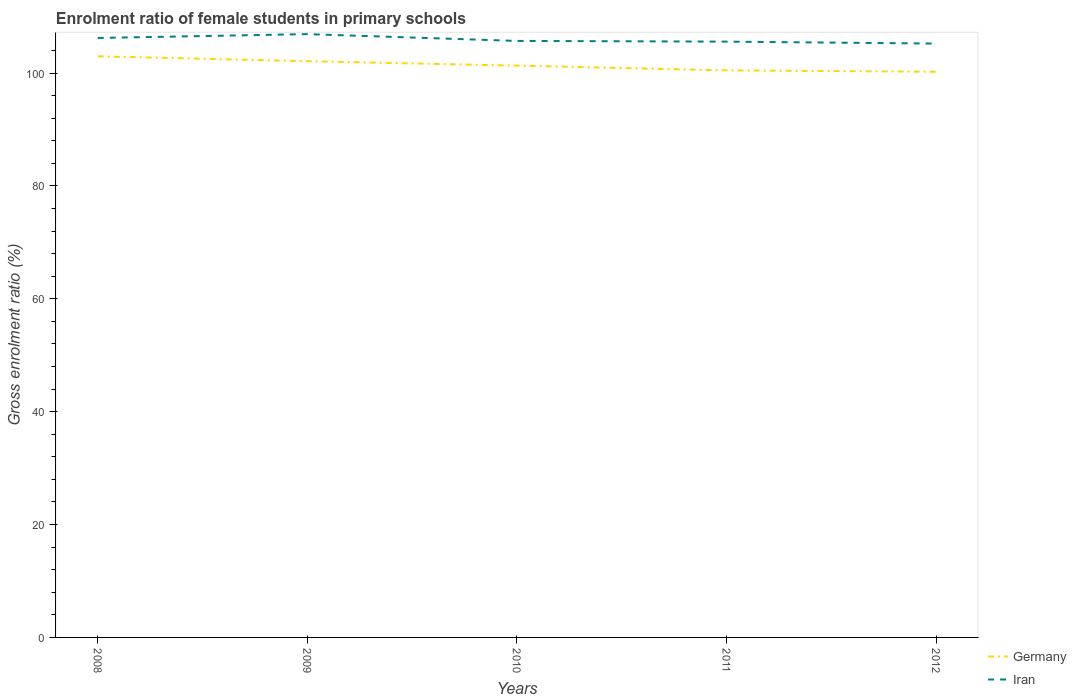Is the number of lines equal to the number of legend labels?
Give a very brief answer. Yes. Across all years, what is the maximum enrolment ratio of female students in primary schools in Iran?
Keep it short and to the point. 105.23. In which year was the enrolment ratio of female students in primary schools in Iran maximum?
Offer a very short reply. 2012. What is the total enrolment ratio of female students in primary schools in Germany in the graph?
Keep it short and to the point. 1.65. What is the difference between the highest and the second highest enrolment ratio of female students in primary schools in Germany?
Your answer should be compact. 2.74. What is the difference between the highest and the lowest enrolment ratio of female students in primary schools in Iran?
Your response must be concise. 2. How many lines are there?
Keep it short and to the point. 2. How many years are there in the graph?
Provide a succinct answer. 5. Are the values on the major ticks of Y-axis written in scientific E-notation?
Offer a terse response. No. Does the graph contain any zero values?
Keep it short and to the point. No. Does the graph contain grids?
Keep it short and to the point. No. How are the legend labels stacked?
Offer a very short reply. Vertical. What is the title of the graph?
Your response must be concise. Enrolment ratio of female students in primary schools. What is the Gross enrolment ratio (%) in Germany in 2008?
Ensure brevity in your answer.  102.98. What is the Gross enrolment ratio (%) of Iran in 2008?
Provide a short and direct response. 106.23. What is the Gross enrolment ratio (%) in Germany in 2009?
Your answer should be compact. 102.11. What is the Gross enrolment ratio (%) in Iran in 2009?
Your answer should be very brief. 106.91. What is the Gross enrolment ratio (%) in Germany in 2010?
Your answer should be compact. 101.33. What is the Gross enrolment ratio (%) in Iran in 2010?
Make the answer very short. 105.7. What is the Gross enrolment ratio (%) in Germany in 2011?
Provide a short and direct response. 100.48. What is the Gross enrolment ratio (%) in Iran in 2011?
Your response must be concise. 105.58. What is the Gross enrolment ratio (%) of Germany in 2012?
Your answer should be compact. 100.24. What is the Gross enrolment ratio (%) of Iran in 2012?
Provide a short and direct response. 105.23. Across all years, what is the maximum Gross enrolment ratio (%) in Germany?
Provide a short and direct response. 102.98. Across all years, what is the maximum Gross enrolment ratio (%) in Iran?
Your answer should be compact. 106.91. Across all years, what is the minimum Gross enrolment ratio (%) in Germany?
Ensure brevity in your answer.  100.24. Across all years, what is the minimum Gross enrolment ratio (%) in Iran?
Offer a terse response. 105.23. What is the total Gross enrolment ratio (%) of Germany in the graph?
Make the answer very short. 507.14. What is the total Gross enrolment ratio (%) of Iran in the graph?
Your response must be concise. 529.65. What is the difference between the Gross enrolment ratio (%) in Germany in 2008 and that in 2009?
Provide a succinct answer. 0.87. What is the difference between the Gross enrolment ratio (%) in Iran in 2008 and that in 2009?
Provide a short and direct response. -0.68. What is the difference between the Gross enrolment ratio (%) of Germany in 2008 and that in 2010?
Offer a terse response. 1.65. What is the difference between the Gross enrolment ratio (%) in Iran in 2008 and that in 2010?
Provide a succinct answer. 0.52. What is the difference between the Gross enrolment ratio (%) in Germany in 2008 and that in 2011?
Your response must be concise. 2.5. What is the difference between the Gross enrolment ratio (%) in Iran in 2008 and that in 2011?
Give a very brief answer. 0.65. What is the difference between the Gross enrolment ratio (%) in Germany in 2008 and that in 2012?
Ensure brevity in your answer.  2.74. What is the difference between the Gross enrolment ratio (%) in Germany in 2009 and that in 2010?
Your response must be concise. 0.78. What is the difference between the Gross enrolment ratio (%) of Iran in 2009 and that in 2010?
Your answer should be very brief. 1.2. What is the difference between the Gross enrolment ratio (%) of Germany in 2009 and that in 2011?
Ensure brevity in your answer.  1.63. What is the difference between the Gross enrolment ratio (%) of Iran in 2009 and that in 2011?
Make the answer very short. 1.33. What is the difference between the Gross enrolment ratio (%) in Germany in 2009 and that in 2012?
Your response must be concise. 1.87. What is the difference between the Gross enrolment ratio (%) in Iran in 2009 and that in 2012?
Give a very brief answer. 1.67. What is the difference between the Gross enrolment ratio (%) in Germany in 2010 and that in 2011?
Provide a succinct answer. 0.85. What is the difference between the Gross enrolment ratio (%) of Iran in 2010 and that in 2011?
Offer a terse response. 0.13. What is the difference between the Gross enrolment ratio (%) of Germany in 2010 and that in 2012?
Offer a very short reply. 1.09. What is the difference between the Gross enrolment ratio (%) of Iran in 2010 and that in 2012?
Your answer should be very brief. 0.47. What is the difference between the Gross enrolment ratio (%) in Germany in 2011 and that in 2012?
Provide a succinct answer. 0.24. What is the difference between the Gross enrolment ratio (%) of Iran in 2011 and that in 2012?
Offer a very short reply. 0.34. What is the difference between the Gross enrolment ratio (%) in Germany in 2008 and the Gross enrolment ratio (%) in Iran in 2009?
Ensure brevity in your answer.  -3.93. What is the difference between the Gross enrolment ratio (%) in Germany in 2008 and the Gross enrolment ratio (%) in Iran in 2010?
Offer a terse response. -2.72. What is the difference between the Gross enrolment ratio (%) in Germany in 2008 and the Gross enrolment ratio (%) in Iran in 2011?
Your response must be concise. -2.6. What is the difference between the Gross enrolment ratio (%) of Germany in 2008 and the Gross enrolment ratio (%) of Iran in 2012?
Make the answer very short. -2.25. What is the difference between the Gross enrolment ratio (%) in Germany in 2009 and the Gross enrolment ratio (%) in Iran in 2010?
Offer a very short reply. -3.59. What is the difference between the Gross enrolment ratio (%) of Germany in 2009 and the Gross enrolment ratio (%) of Iran in 2011?
Ensure brevity in your answer.  -3.47. What is the difference between the Gross enrolment ratio (%) of Germany in 2009 and the Gross enrolment ratio (%) of Iran in 2012?
Provide a short and direct response. -3.12. What is the difference between the Gross enrolment ratio (%) of Germany in 2010 and the Gross enrolment ratio (%) of Iran in 2011?
Keep it short and to the point. -4.25. What is the difference between the Gross enrolment ratio (%) of Germany in 2010 and the Gross enrolment ratio (%) of Iran in 2012?
Provide a succinct answer. -3.91. What is the difference between the Gross enrolment ratio (%) in Germany in 2011 and the Gross enrolment ratio (%) in Iran in 2012?
Your response must be concise. -4.75. What is the average Gross enrolment ratio (%) of Germany per year?
Ensure brevity in your answer.  101.43. What is the average Gross enrolment ratio (%) of Iran per year?
Your answer should be compact. 105.93. In the year 2008, what is the difference between the Gross enrolment ratio (%) of Germany and Gross enrolment ratio (%) of Iran?
Give a very brief answer. -3.24. In the year 2009, what is the difference between the Gross enrolment ratio (%) of Germany and Gross enrolment ratio (%) of Iran?
Your response must be concise. -4.8. In the year 2010, what is the difference between the Gross enrolment ratio (%) of Germany and Gross enrolment ratio (%) of Iran?
Offer a very short reply. -4.38. In the year 2011, what is the difference between the Gross enrolment ratio (%) in Germany and Gross enrolment ratio (%) in Iran?
Your response must be concise. -5.1. In the year 2012, what is the difference between the Gross enrolment ratio (%) of Germany and Gross enrolment ratio (%) of Iran?
Your answer should be very brief. -4.99. What is the ratio of the Gross enrolment ratio (%) in Germany in 2008 to that in 2009?
Provide a succinct answer. 1.01. What is the ratio of the Gross enrolment ratio (%) in Iran in 2008 to that in 2009?
Provide a succinct answer. 0.99. What is the ratio of the Gross enrolment ratio (%) in Germany in 2008 to that in 2010?
Your answer should be compact. 1.02. What is the ratio of the Gross enrolment ratio (%) of Germany in 2008 to that in 2011?
Offer a very short reply. 1.02. What is the ratio of the Gross enrolment ratio (%) of Germany in 2008 to that in 2012?
Your response must be concise. 1.03. What is the ratio of the Gross enrolment ratio (%) of Iran in 2008 to that in 2012?
Make the answer very short. 1.01. What is the ratio of the Gross enrolment ratio (%) of Germany in 2009 to that in 2010?
Give a very brief answer. 1.01. What is the ratio of the Gross enrolment ratio (%) in Iran in 2009 to that in 2010?
Make the answer very short. 1.01. What is the ratio of the Gross enrolment ratio (%) in Germany in 2009 to that in 2011?
Offer a terse response. 1.02. What is the ratio of the Gross enrolment ratio (%) in Iran in 2009 to that in 2011?
Provide a succinct answer. 1.01. What is the ratio of the Gross enrolment ratio (%) of Germany in 2009 to that in 2012?
Ensure brevity in your answer.  1.02. What is the ratio of the Gross enrolment ratio (%) of Iran in 2009 to that in 2012?
Your answer should be compact. 1.02. What is the ratio of the Gross enrolment ratio (%) of Germany in 2010 to that in 2011?
Provide a short and direct response. 1.01. What is the ratio of the Gross enrolment ratio (%) in Germany in 2010 to that in 2012?
Give a very brief answer. 1.01. What is the ratio of the Gross enrolment ratio (%) of Iran in 2010 to that in 2012?
Provide a succinct answer. 1. What is the difference between the highest and the second highest Gross enrolment ratio (%) of Germany?
Offer a very short reply. 0.87. What is the difference between the highest and the second highest Gross enrolment ratio (%) of Iran?
Provide a short and direct response. 0.68. What is the difference between the highest and the lowest Gross enrolment ratio (%) in Germany?
Offer a terse response. 2.74. What is the difference between the highest and the lowest Gross enrolment ratio (%) in Iran?
Your answer should be compact. 1.67. 